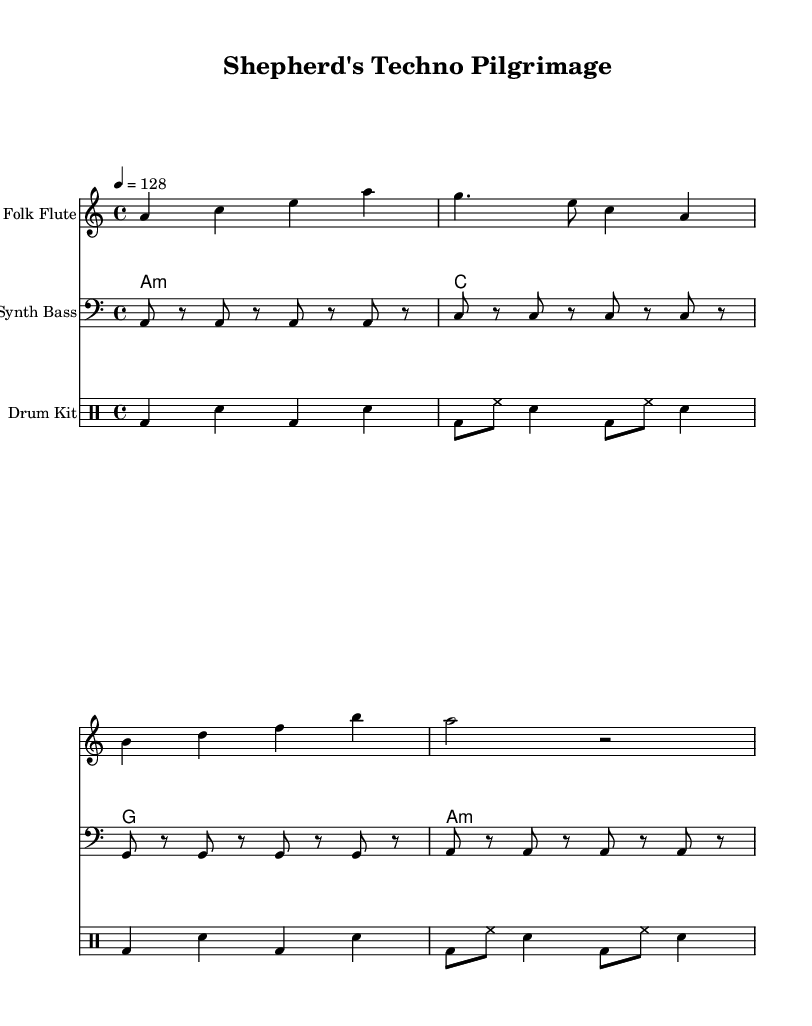What is the key signature of this music? The key signature is indicated at the beginning with a single flat, meaning the piece is in A minor.
Answer: A minor What is the time signature of this music? The time signature is found at the beginning of the score and is written as 4/4, which means there are four beats in each measure.
Answer: 4/4 What is the tempo marking for this piece? The tempo is indicated by "4 = 128," suggesting a lively pace where a quarter note gets 128 beats per minute.
Answer: 128 How many measures are in the folk flute part? Counting the measures in the folk flute staff, there are four distinct measures written out.
Answer: 4 What type of drum pattern is used in this piece? The drum part is structured with a combination of kick drum (bd) and snare (sn) patterns typical of house music, and includes hi-hats (hh).
Answer: House What traditional instrument is featured in this music? The sheet music indicates a "Folk Flute" as one of the instruments, blending traditional sounds into the electronic composition.
Answer: Folk Flute Which chord is played throughout the first measure by the acoustic guitar? The first measure indicates an A minor chord, reflecting the piece's tonal center.
Answer: A minor 